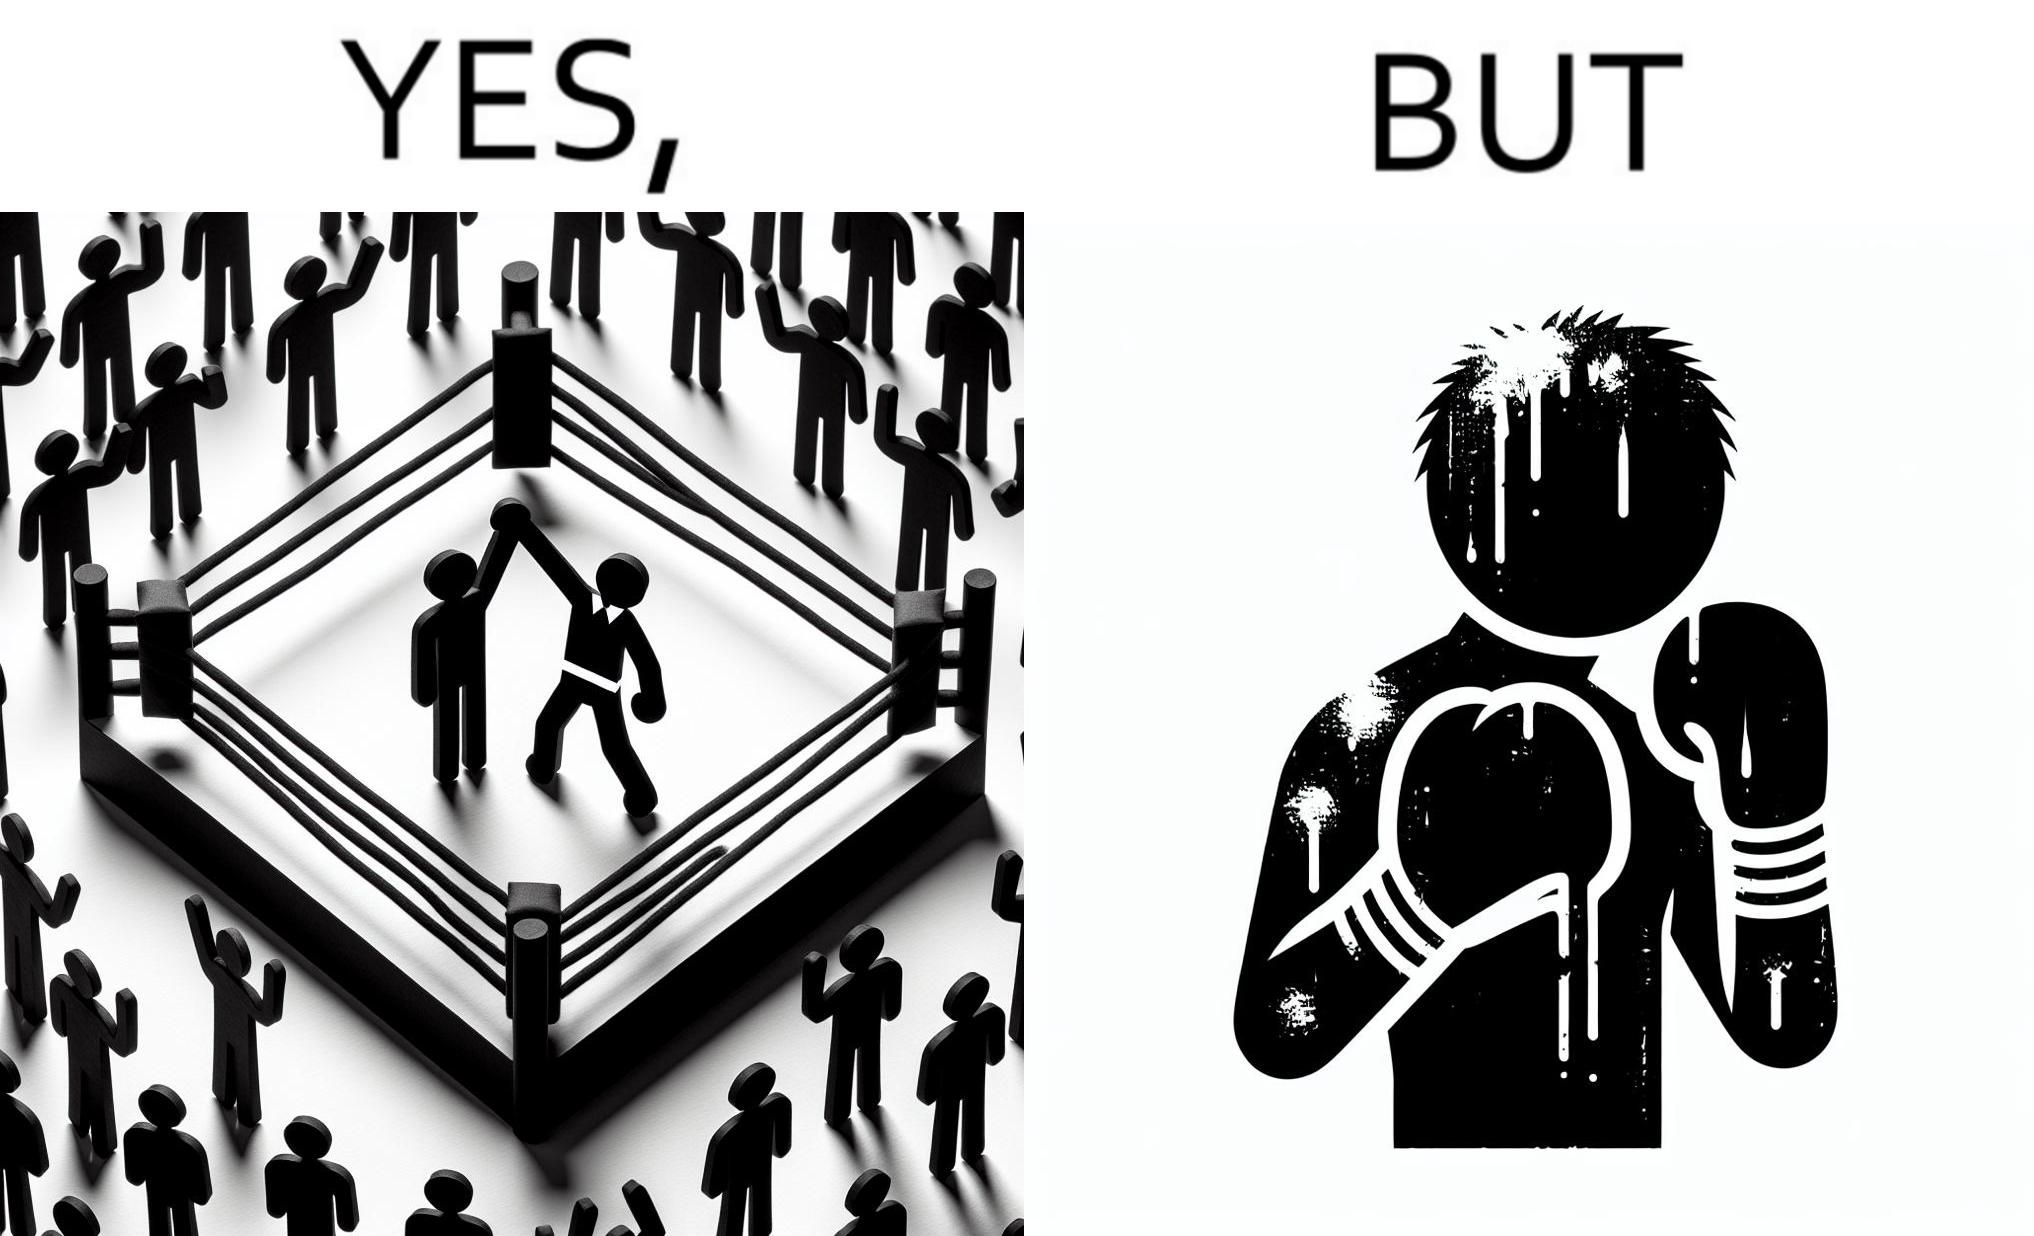What is the satirical meaning behind this image? The image is ironic because even though a boxer has won the match and it is supposed to be a moment of celebration, the boxer got bruised in several places during the match. This is an illustration of what hurdles a person has to go through in order to succeed. 